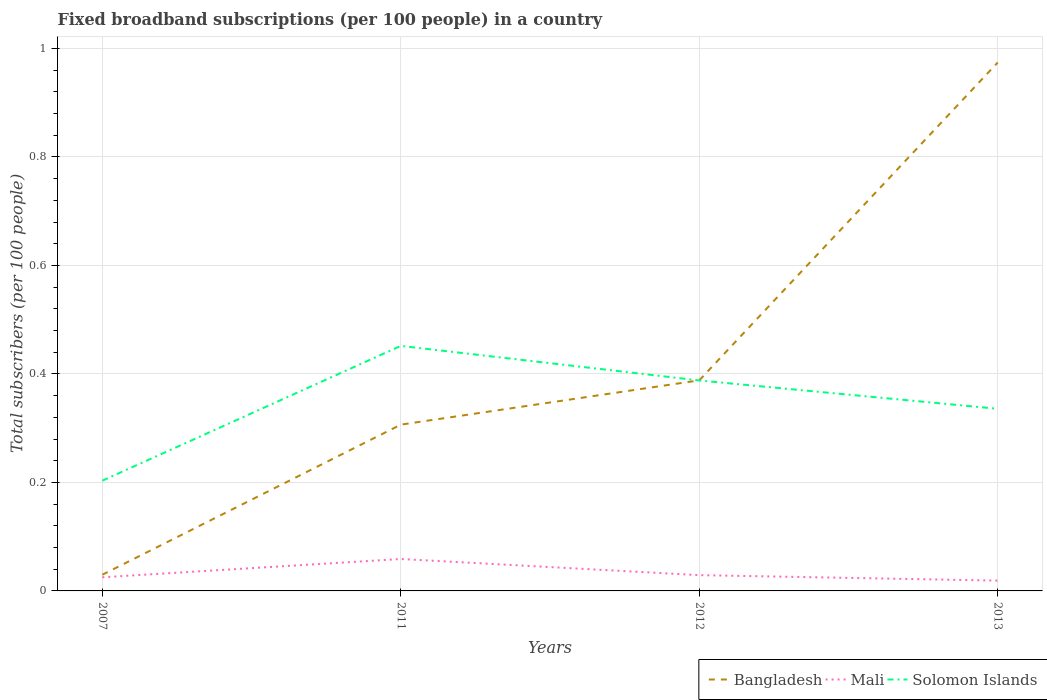Across all years, what is the maximum number of broadband subscriptions in Mali?
Offer a terse response. 0.02. What is the total number of broadband subscriptions in Solomon Islands in the graph?
Provide a succinct answer. 0.05. What is the difference between the highest and the second highest number of broadband subscriptions in Solomon Islands?
Keep it short and to the point. 0.25. How many years are there in the graph?
Give a very brief answer. 4. What is the difference between two consecutive major ticks on the Y-axis?
Ensure brevity in your answer.  0.2. Does the graph contain any zero values?
Ensure brevity in your answer.  No. How many legend labels are there?
Your answer should be very brief. 3. How are the legend labels stacked?
Keep it short and to the point. Horizontal. What is the title of the graph?
Offer a very short reply. Fixed broadband subscriptions (per 100 people) in a country. What is the label or title of the X-axis?
Your answer should be compact. Years. What is the label or title of the Y-axis?
Your answer should be very brief. Total subscribers (per 100 people). What is the Total subscribers (per 100 people) of Bangladesh in 2007?
Ensure brevity in your answer.  0.03. What is the Total subscribers (per 100 people) of Mali in 2007?
Keep it short and to the point. 0.03. What is the Total subscribers (per 100 people) in Solomon Islands in 2007?
Your answer should be very brief. 0.2. What is the Total subscribers (per 100 people) in Bangladesh in 2011?
Make the answer very short. 0.31. What is the Total subscribers (per 100 people) of Mali in 2011?
Offer a very short reply. 0.06. What is the Total subscribers (per 100 people) in Solomon Islands in 2011?
Offer a very short reply. 0.45. What is the Total subscribers (per 100 people) in Bangladesh in 2012?
Provide a succinct answer. 0.39. What is the Total subscribers (per 100 people) of Mali in 2012?
Ensure brevity in your answer.  0.03. What is the Total subscribers (per 100 people) in Solomon Islands in 2012?
Make the answer very short. 0.39. What is the Total subscribers (per 100 people) in Bangladesh in 2013?
Ensure brevity in your answer.  0.97. What is the Total subscribers (per 100 people) in Mali in 2013?
Your response must be concise. 0.02. What is the Total subscribers (per 100 people) of Solomon Islands in 2013?
Provide a short and direct response. 0.34. Across all years, what is the maximum Total subscribers (per 100 people) of Bangladesh?
Your answer should be compact. 0.97. Across all years, what is the maximum Total subscribers (per 100 people) of Mali?
Your answer should be compact. 0.06. Across all years, what is the maximum Total subscribers (per 100 people) in Solomon Islands?
Your answer should be compact. 0.45. Across all years, what is the minimum Total subscribers (per 100 people) in Bangladesh?
Give a very brief answer. 0.03. Across all years, what is the minimum Total subscribers (per 100 people) in Mali?
Offer a very short reply. 0.02. Across all years, what is the minimum Total subscribers (per 100 people) in Solomon Islands?
Make the answer very short. 0.2. What is the total Total subscribers (per 100 people) of Bangladesh in the graph?
Provide a short and direct response. 1.7. What is the total Total subscribers (per 100 people) of Mali in the graph?
Ensure brevity in your answer.  0.13. What is the total Total subscribers (per 100 people) in Solomon Islands in the graph?
Your answer should be very brief. 1.38. What is the difference between the Total subscribers (per 100 people) of Bangladesh in 2007 and that in 2011?
Give a very brief answer. -0.28. What is the difference between the Total subscribers (per 100 people) of Mali in 2007 and that in 2011?
Your response must be concise. -0.03. What is the difference between the Total subscribers (per 100 people) of Solomon Islands in 2007 and that in 2011?
Your answer should be compact. -0.25. What is the difference between the Total subscribers (per 100 people) of Bangladesh in 2007 and that in 2012?
Your response must be concise. -0.36. What is the difference between the Total subscribers (per 100 people) of Mali in 2007 and that in 2012?
Your answer should be very brief. -0. What is the difference between the Total subscribers (per 100 people) of Solomon Islands in 2007 and that in 2012?
Ensure brevity in your answer.  -0.18. What is the difference between the Total subscribers (per 100 people) of Bangladesh in 2007 and that in 2013?
Keep it short and to the point. -0.94. What is the difference between the Total subscribers (per 100 people) of Mali in 2007 and that in 2013?
Your answer should be compact. 0.01. What is the difference between the Total subscribers (per 100 people) in Solomon Islands in 2007 and that in 2013?
Your answer should be compact. -0.13. What is the difference between the Total subscribers (per 100 people) of Bangladesh in 2011 and that in 2012?
Give a very brief answer. -0.08. What is the difference between the Total subscribers (per 100 people) of Mali in 2011 and that in 2012?
Give a very brief answer. 0.03. What is the difference between the Total subscribers (per 100 people) in Solomon Islands in 2011 and that in 2012?
Your response must be concise. 0.06. What is the difference between the Total subscribers (per 100 people) in Bangladesh in 2011 and that in 2013?
Your answer should be compact. -0.67. What is the difference between the Total subscribers (per 100 people) in Mali in 2011 and that in 2013?
Make the answer very short. 0.04. What is the difference between the Total subscribers (per 100 people) of Solomon Islands in 2011 and that in 2013?
Provide a succinct answer. 0.12. What is the difference between the Total subscribers (per 100 people) in Bangladesh in 2012 and that in 2013?
Ensure brevity in your answer.  -0.59. What is the difference between the Total subscribers (per 100 people) of Mali in 2012 and that in 2013?
Give a very brief answer. 0.01. What is the difference between the Total subscribers (per 100 people) of Solomon Islands in 2012 and that in 2013?
Your response must be concise. 0.05. What is the difference between the Total subscribers (per 100 people) of Bangladesh in 2007 and the Total subscribers (per 100 people) of Mali in 2011?
Give a very brief answer. -0.03. What is the difference between the Total subscribers (per 100 people) in Bangladesh in 2007 and the Total subscribers (per 100 people) in Solomon Islands in 2011?
Ensure brevity in your answer.  -0.42. What is the difference between the Total subscribers (per 100 people) in Mali in 2007 and the Total subscribers (per 100 people) in Solomon Islands in 2011?
Ensure brevity in your answer.  -0.43. What is the difference between the Total subscribers (per 100 people) in Bangladesh in 2007 and the Total subscribers (per 100 people) in Mali in 2012?
Offer a terse response. 0. What is the difference between the Total subscribers (per 100 people) of Bangladesh in 2007 and the Total subscribers (per 100 people) of Solomon Islands in 2012?
Provide a short and direct response. -0.36. What is the difference between the Total subscribers (per 100 people) of Mali in 2007 and the Total subscribers (per 100 people) of Solomon Islands in 2012?
Your answer should be very brief. -0.36. What is the difference between the Total subscribers (per 100 people) of Bangladesh in 2007 and the Total subscribers (per 100 people) of Mali in 2013?
Provide a succinct answer. 0.01. What is the difference between the Total subscribers (per 100 people) of Bangladesh in 2007 and the Total subscribers (per 100 people) of Solomon Islands in 2013?
Your answer should be very brief. -0.31. What is the difference between the Total subscribers (per 100 people) in Mali in 2007 and the Total subscribers (per 100 people) in Solomon Islands in 2013?
Provide a succinct answer. -0.31. What is the difference between the Total subscribers (per 100 people) of Bangladesh in 2011 and the Total subscribers (per 100 people) of Mali in 2012?
Offer a terse response. 0.28. What is the difference between the Total subscribers (per 100 people) in Bangladesh in 2011 and the Total subscribers (per 100 people) in Solomon Islands in 2012?
Provide a succinct answer. -0.08. What is the difference between the Total subscribers (per 100 people) in Mali in 2011 and the Total subscribers (per 100 people) in Solomon Islands in 2012?
Your response must be concise. -0.33. What is the difference between the Total subscribers (per 100 people) in Bangladesh in 2011 and the Total subscribers (per 100 people) in Mali in 2013?
Offer a very short reply. 0.29. What is the difference between the Total subscribers (per 100 people) in Bangladesh in 2011 and the Total subscribers (per 100 people) in Solomon Islands in 2013?
Provide a short and direct response. -0.03. What is the difference between the Total subscribers (per 100 people) in Mali in 2011 and the Total subscribers (per 100 people) in Solomon Islands in 2013?
Offer a very short reply. -0.28. What is the difference between the Total subscribers (per 100 people) in Bangladesh in 2012 and the Total subscribers (per 100 people) in Mali in 2013?
Your answer should be very brief. 0.37. What is the difference between the Total subscribers (per 100 people) of Bangladesh in 2012 and the Total subscribers (per 100 people) of Solomon Islands in 2013?
Provide a succinct answer. 0.05. What is the difference between the Total subscribers (per 100 people) in Mali in 2012 and the Total subscribers (per 100 people) in Solomon Islands in 2013?
Provide a short and direct response. -0.31. What is the average Total subscribers (per 100 people) of Bangladesh per year?
Your response must be concise. 0.42. What is the average Total subscribers (per 100 people) in Mali per year?
Your response must be concise. 0.03. What is the average Total subscribers (per 100 people) in Solomon Islands per year?
Give a very brief answer. 0.34. In the year 2007, what is the difference between the Total subscribers (per 100 people) in Bangladesh and Total subscribers (per 100 people) in Mali?
Your answer should be compact. 0. In the year 2007, what is the difference between the Total subscribers (per 100 people) in Bangladesh and Total subscribers (per 100 people) in Solomon Islands?
Your answer should be compact. -0.17. In the year 2007, what is the difference between the Total subscribers (per 100 people) in Mali and Total subscribers (per 100 people) in Solomon Islands?
Keep it short and to the point. -0.18. In the year 2011, what is the difference between the Total subscribers (per 100 people) of Bangladesh and Total subscribers (per 100 people) of Mali?
Offer a very short reply. 0.25. In the year 2011, what is the difference between the Total subscribers (per 100 people) in Bangladesh and Total subscribers (per 100 people) in Solomon Islands?
Ensure brevity in your answer.  -0.15. In the year 2011, what is the difference between the Total subscribers (per 100 people) in Mali and Total subscribers (per 100 people) in Solomon Islands?
Your response must be concise. -0.39. In the year 2012, what is the difference between the Total subscribers (per 100 people) in Bangladesh and Total subscribers (per 100 people) in Mali?
Make the answer very short. 0.36. In the year 2012, what is the difference between the Total subscribers (per 100 people) of Bangladesh and Total subscribers (per 100 people) of Solomon Islands?
Offer a very short reply. 0. In the year 2012, what is the difference between the Total subscribers (per 100 people) of Mali and Total subscribers (per 100 people) of Solomon Islands?
Your response must be concise. -0.36. In the year 2013, what is the difference between the Total subscribers (per 100 people) of Bangladesh and Total subscribers (per 100 people) of Mali?
Your response must be concise. 0.95. In the year 2013, what is the difference between the Total subscribers (per 100 people) in Bangladesh and Total subscribers (per 100 people) in Solomon Islands?
Provide a short and direct response. 0.64. In the year 2013, what is the difference between the Total subscribers (per 100 people) of Mali and Total subscribers (per 100 people) of Solomon Islands?
Your response must be concise. -0.32. What is the ratio of the Total subscribers (per 100 people) in Bangladesh in 2007 to that in 2011?
Your answer should be very brief. 0.1. What is the ratio of the Total subscribers (per 100 people) in Mali in 2007 to that in 2011?
Provide a succinct answer. 0.43. What is the ratio of the Total subscribers (per 100 people) in Solomon Islands in 2007 to that in 2011?
Give a very brief answer. 0.45. What is the ratio of the Total subscribers (per 100 people) in Bangladesh in 2007 to that in 2012?
Provide a succinct answer. 0.08. What is the ratio of the Total subscribers (per 100 people) in Mali in 2007 to that in 2012?
Give a very brief answer. 0.86. What is the ratio of the Total subscribers (per 100 people) of Solomon Islands in 2007 to that in 2012?
Offer a terse response. 0.52. What is the ratio of the Total subscribers (per 100 people) of Bangladesh in 2007 to that in 2013?
Give a very brief answer. 0.03. What is the ratio of the Total subscribers (per 100 people) of Mali in 2007 to that in 2013?
Give a very brief answer. 1.32. What is the ratio of the Total subscribers (per 100 people) of Solomon Islands in 2007 to that in 2013?
Ensure brevity in your answer.  0.61. What is the ratio of the Total subscribers (per 100 people) in Bangladesh in 2011 to that in 2012?
Offer a very short reply. 0.79. What is the ratio of the Total subscribers (per 100 people) of Mali in 2011 to that in 2012?
Offer a very short reply. 2.02. What is the ratio of the Total subscribers (per 100 people) of Solomon Islands in 2011 to that in 2012?
Provide a succinct answer. 1.16. What is the ratio of the Total subscribers (per 100 people) of Bangladesh in 2011 to that in 2013?
Your answer should be very brief. 0.31. What is the ratio of the Total subscribers (per 100 people) of Mali in 2011 to that in 2013?
Offer a very short reply. 3.09. What is the ratio of the Total subscribers (per 100 people) in Solomon Islands in 2011 to that in 2013?
Offer a very short reply. 1.35. What is the ratio of the Total subscribers (per 100 people) in Bangladesh in 2012 to that in 2013?
Your answer should be compact. 0.4. What is the ratio of the Total subscribers (per 100 people) of Mali in 2012 to that in 2013?
Offer a very short reply. 1.53. What is the ratio of the Total subscribers (per 100 people) in Solomon Islands in 2012 to that in 2013?
Give a very brief answer. 1.16. What is the difference between the highest and the second highest Total subscribers (per 100 people) in Bangladesh?
Your answer should be compact. 0.59. What is the difference between the highest and the second highest Total subscribers (per 100 people) of Mali?
Keep it short and to the point. 0.03. What is the difference between the highest and the second highest Total subscribers (per 100 people) of Solomon Islands?
Provide a succinct answer. 0.06. What is the difference between the highest and the lowest Total subscribers (per 100 people) of Bangladesh?
Your answer should be compact. 0.94. What is the difference between the highest and the lowest Total subscribers (per 100 people) of Mali?
Provide a short and direct response. 0.04. What is the difference between the highest and the lowest Total subscribers (per 100 people) of Solomon Islands?
Your answer should be very brief. 0.25. 